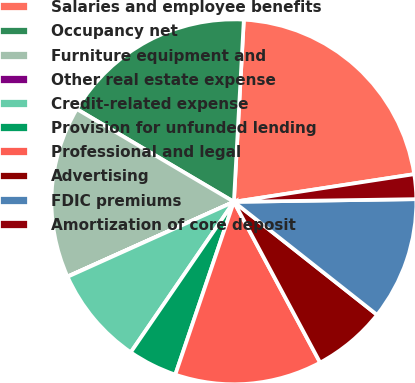Convert chart. <chart><loc_0><loc_0><loc_500><loc_500><pie_chart><fcel>Salaries and employee benefits<fcel>Occupancy net<fcel>Furniture equipment and<fcel>Other real estate expense<fcel>Credit-related expense<fcel>Provision for unfunded lending<fcel>Professional and legal<fcel>Advertising<fcel>FDIC premiums<fcel>Amortization of core deposit<nl><fcel>21.71%<fcel>17.38%<fcel>15.21%<fcel>0.02%<fcel>8.7%<fcel>4.36%<fcel>13.04%<fcel>6.53%<fcel>10.87%<fcel>2.19%<nl></chart> 